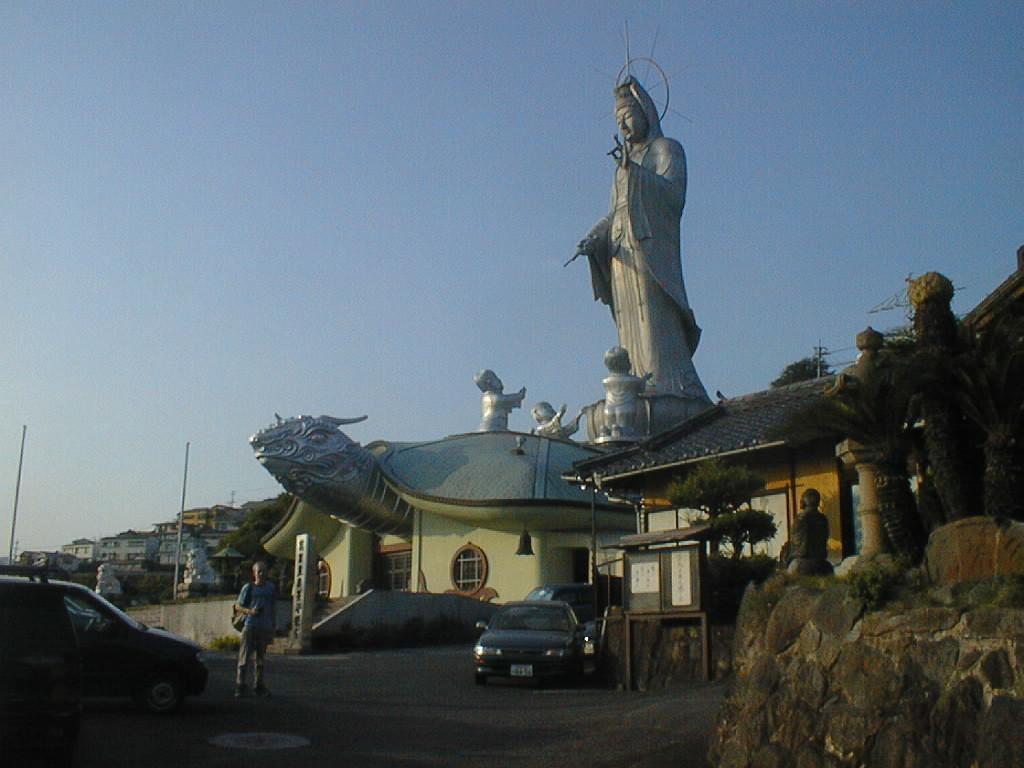In one or two sentences, can you explain what this image depicts? In this picture we can see houses, there are two vehicles in the front, we can see a person is standing in the middle, on the right side there is a statue, on the left side there are two poles, we can see the sky at the top of the picture. 